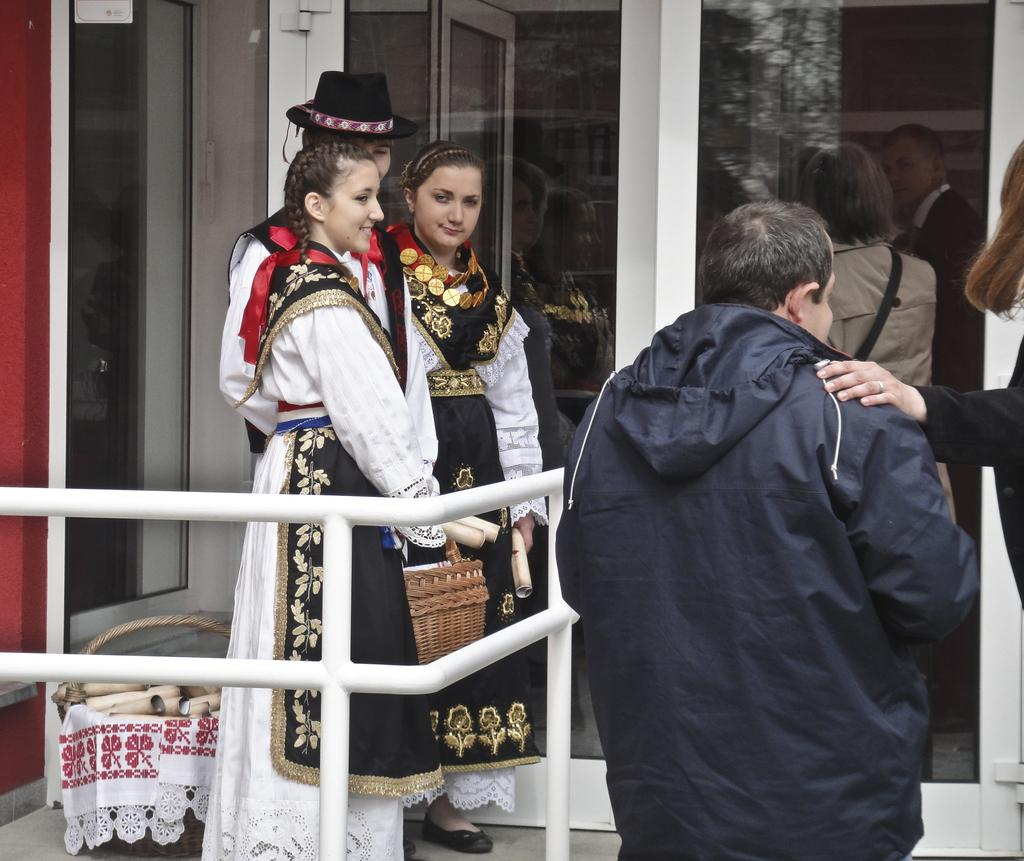How many people are in the image? There are 5 persons in the image. What can be seen near the people in the image? There is railing visible in the image. What objects can be seen in the background of the image? There are glasses and a basket in the background of the image. What is inside the basket? The basket contains a few things. What type of guitar can be heard playing in the background of the image? There is no guitar or sound present in the image; it is a still image. 